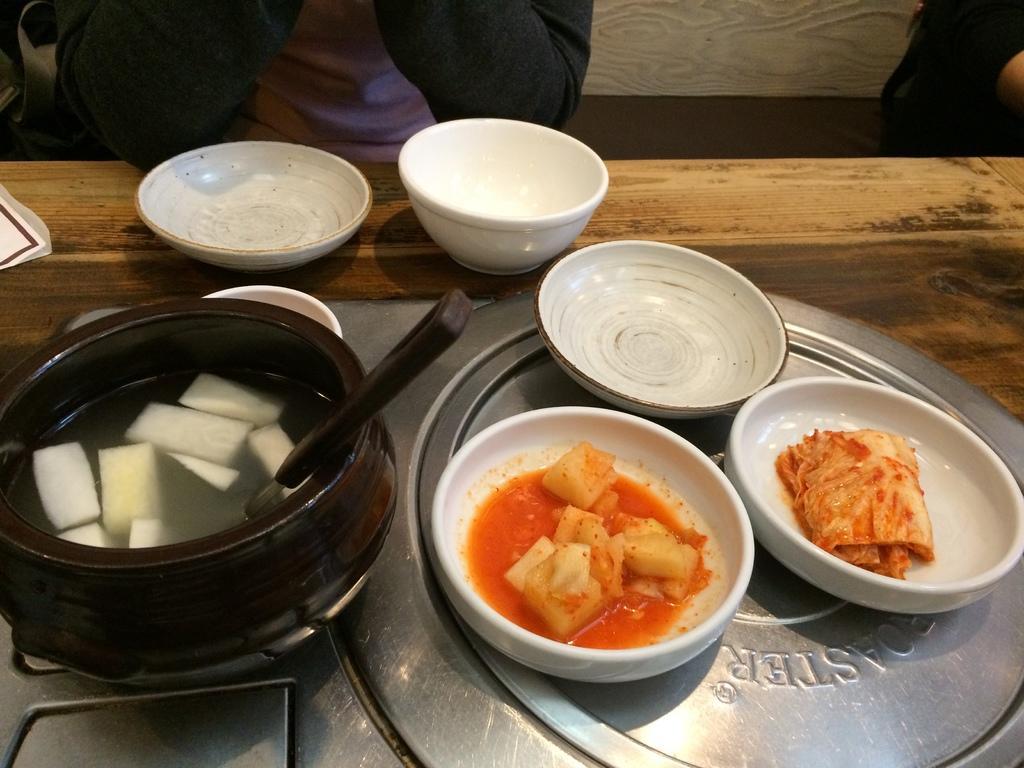Can you describe this image briefly? In this picture we can see a table, there are plates and bowls placed on the table, we can see some food in these two plates, we can see a spoon and soup in this bowl, there are two persons sitting in the background, on the left side there is a paper. 